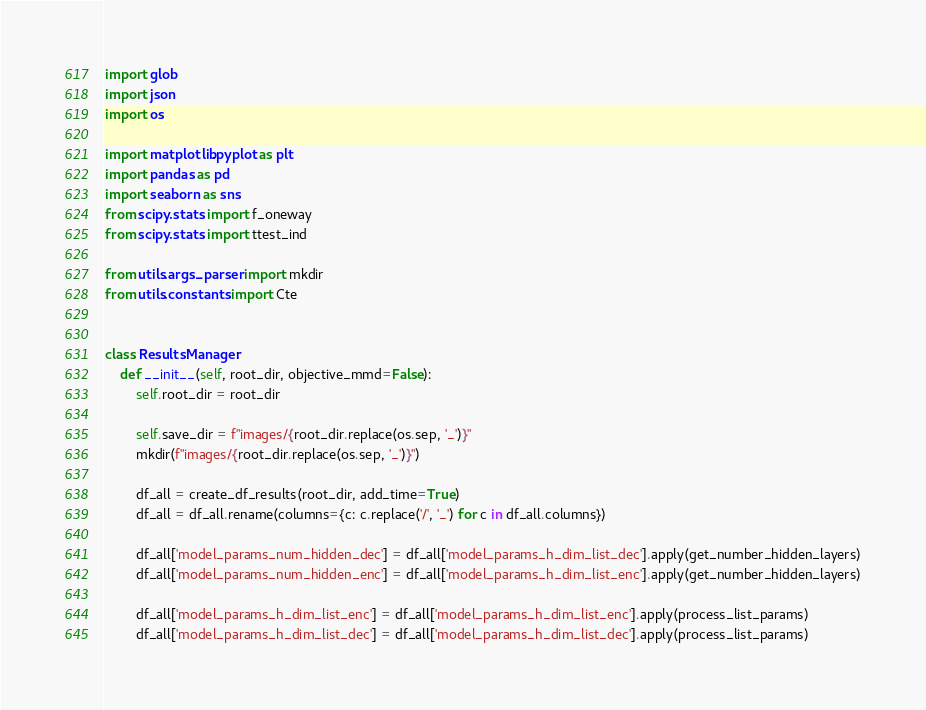Convert code to text. <code><loc_0><loc_0><loc_500><loc_500><_Python_>import glob
import json
import os

import matplotlib.pyplot as plt
import pandas as pd
import seaborn as sns
from scipy.stats import f_oneway
from scipy.stats import ttest_ind

from utils.args_parser import mkdir
from utils.constants import Cte


class ResultsManager:
    def __init__(self, root_dir, objective_mmd=False):
        self.root_dir = root_dir

        self.save_dir = f"images/{root_dir.replace(os.sep, '_')}"
        mkdir(f"images/{root_dir.replace(os.sep, '_')}")

        df_all = create_df_results(root_dir, add_time=True)
        df_all = df_all.rename(columns={c: c.replace('/', '_') for c in df_all.columns})

        df_all['model_params_num_hidden_dec'] = df_all['model_params_h_dim_list_dec'].apply(get_number_hidden_layers)
        df_all['model_params_num_hidden_enc'] = df_all['model_params_h_dim_list_enc'].apply(get_number_hidden_layers)

        df_all['model_params_h_dim_list_enc'] = df_all['model_params_h_dim_list_enc'].apply(process_list_params)
        df_all['model_params_h_dim_list_dec'] = df_all['model_params_h_dim_list_dec'].apply(process_list_params)</code> 